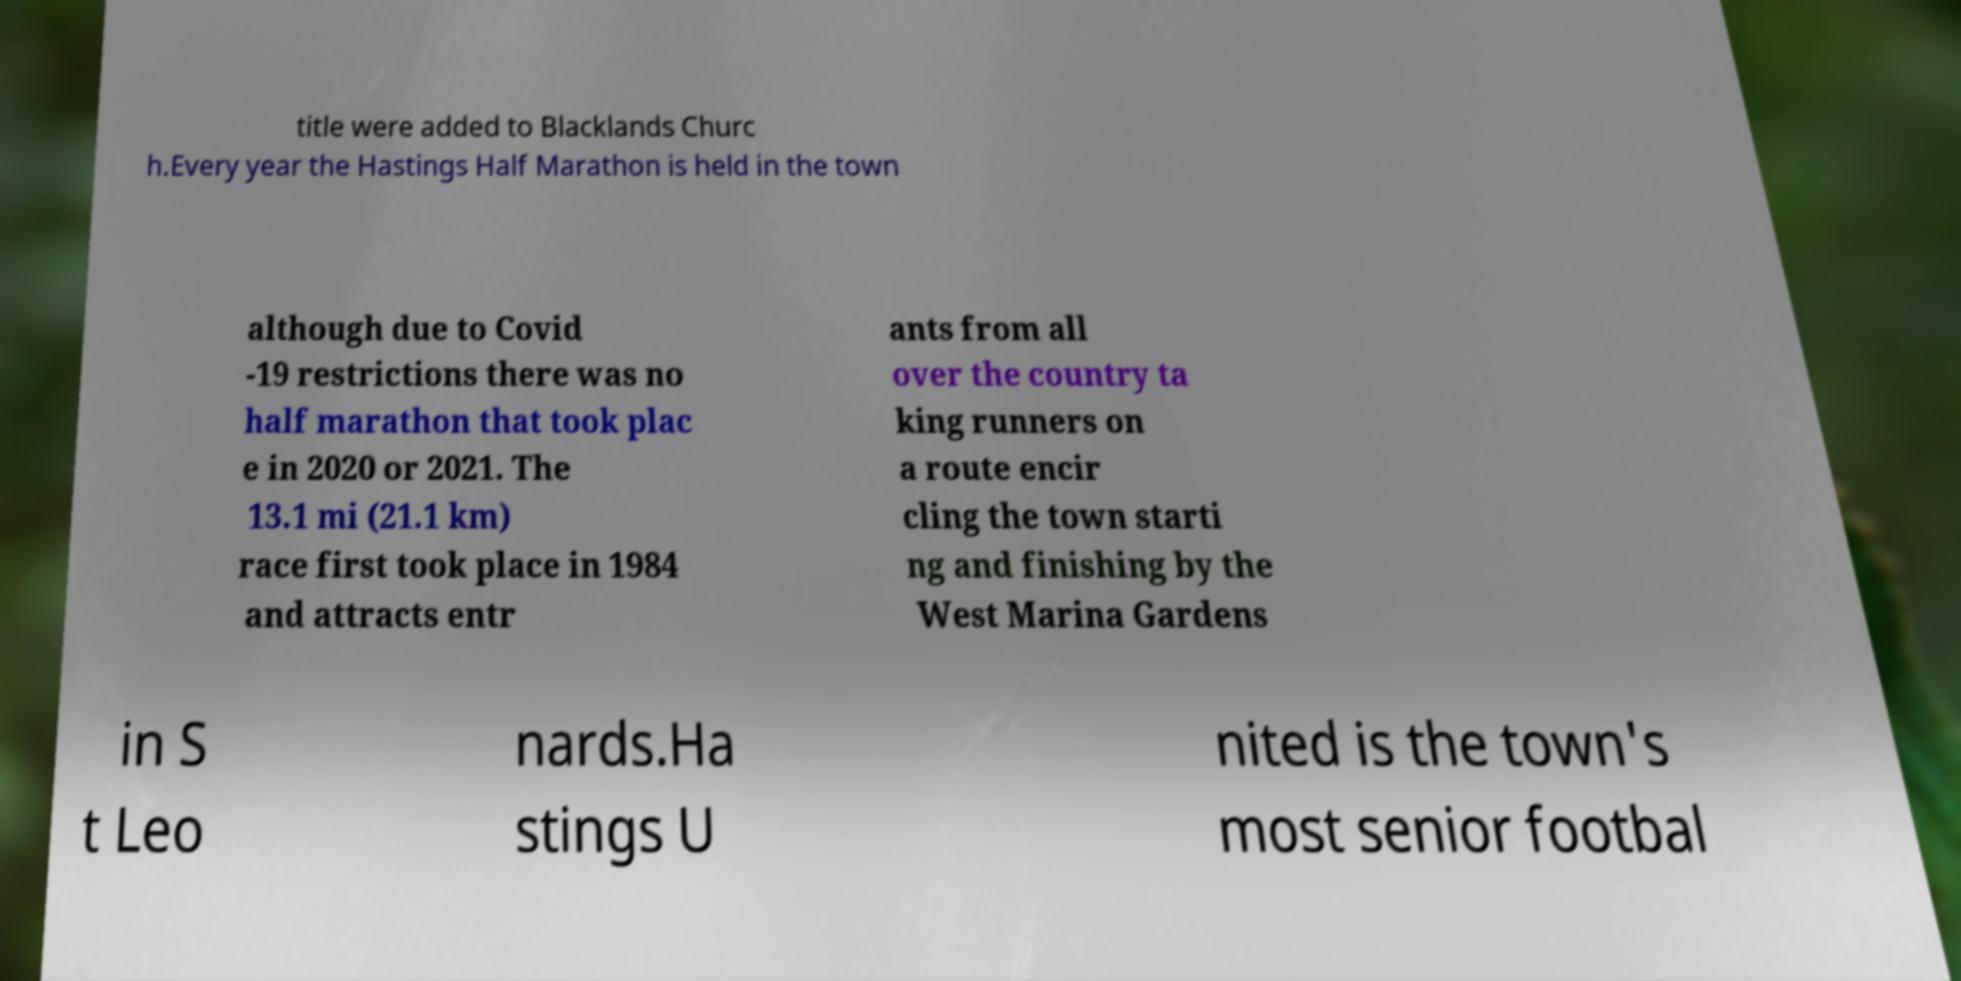Could you extract and type out the text from this image? title were added to Blacklands Churc h.Every year the Hastings Half Marathon is held in the town although due to Covid -19 restrictions there was no half marathon that took plac e in 2020 or 2021. The 13.1 mi (21.1 km) race first took place in 1984 and attracts entr ants from all over the country ta king runners on a route encir cling the town starti ng and finishing by the West Marina Gardens in S t Leo nards.Ha stings U nited is the town's most senior footbal 